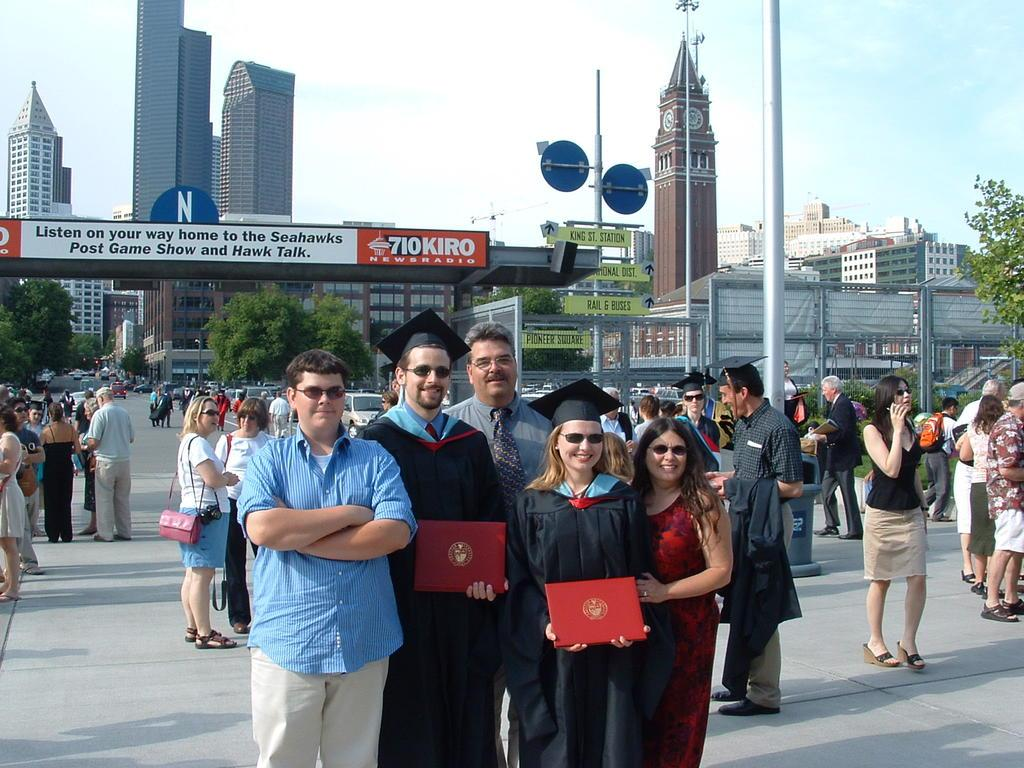<image>
Summarize the visual content of the image. Students are graduating under a poster about the Seahawks. 